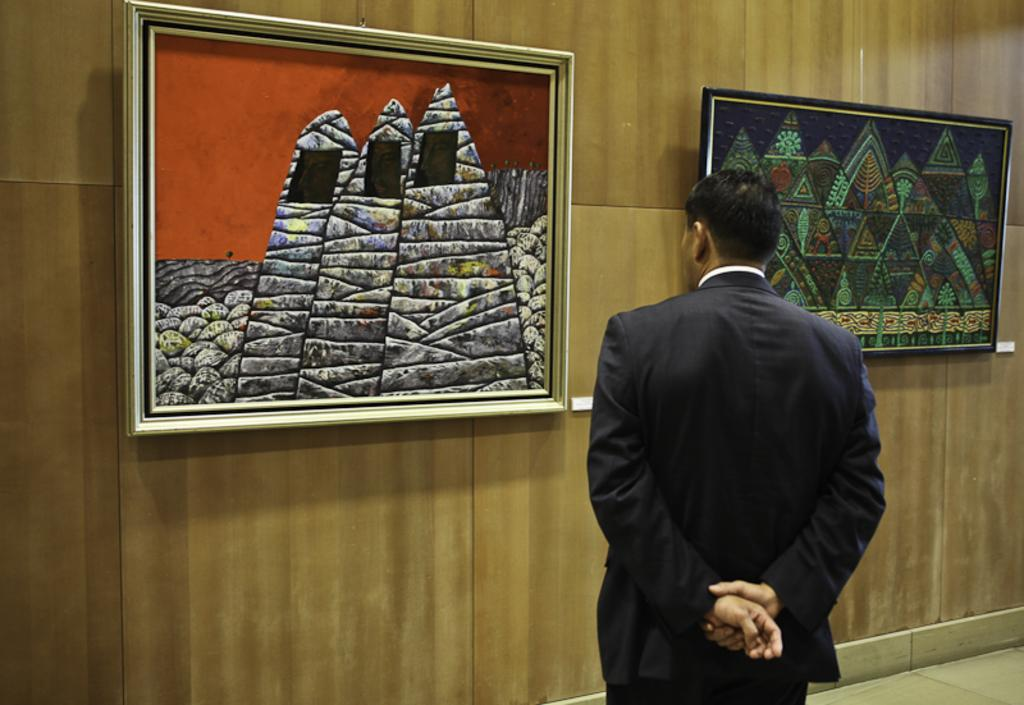What is the main subject of the image? There is a man standing in the image. What can be seen on the wall in the image? There are frames on the wall in the image. What type of mask is the man wearing in the image? There is no mask present in the image; the man is not wearing one. What type of cattle can be seen grazing in the background of the image? There is no background or cattle present in the image; it only features a man standing and frames on the wall. 